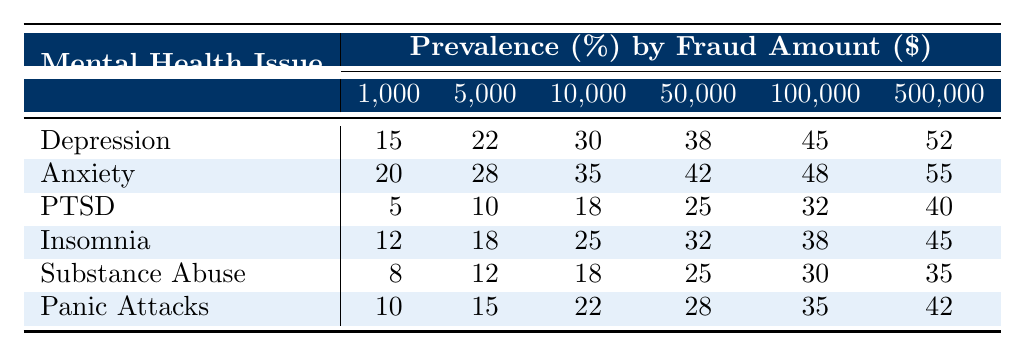What is the prevalence of Depression among victims who experienced $100,000 in fraud? The table indicates that the prevalence of Depression at the $100,000 fraud amount is 45%.
Answer: 45% Which mental health issue has the highest prevalence at a fraud amount of $500,000? By looking at the $500,000 column, Anxiety has the highest prevalence at 55%.
Answer: Anxiety What is the difference in prevalence between PTSD and Insomnia for a fraud amount of $10,000? The prevalence of PTSD at $10,000 is 18%, while for Insomnia it is 25%. The difference is 25% - 18% = 7%.
Answer: 7% Is the prevalence of Substance Abuse higher than that of Panic Attacks at a fraud amount of $50,000? At $50,000, the prevalence for Substance Abuse is 25%, and for Panic Attacks, it is 28%. Since 25% is less than 28%, the answer is no.
Answer: No What is the average prevalence of anxiety across all fraud amounts? To find the average, sum the prevalence for Anxiety at all amounts: (20 + 28 + 35 + 42 + 48 + 55) = 228. There are 6 amounts, so the average is 228/6 = 38.
Answer: 38% How does the prevalence of Depression change as the fraud amount increases from $1,000 to $500,000? The prevalence of Depression increases from 15% at $1,000 to 52% at $500,000. This indicates an upward trend, demonstrating a strong relation between higher fraud amounts and increased prevalence.
Answer: Increases Which two mental health issues have the lowest overall prevalence across all fraud amounts? By reviewing the table, PTSD (5%, 10%, 18%, 25%, 32%, 40%) and Substance Abuse (8%, 12%, 18%, 25%, 30%, 35%) have the lowest prevalence.
Answer: PTSD and Substance Abuse What is the total prevalence of mental health issues at a fraud amount of $50,000? Totaling the prevalence for all issues at $50,000 gives: 38 (Depression) + 42 (Anxiety) + 25 (PTSD) + 32 (Insomnia) + 25 (Substance Abuse) + 28 (Panic Attacks) = 190%.
Answer: 190% If we compare the prevalence of PTSD and Insomnia at the fraud amount of $100,000, which has a higher percentage? At $100,000, PTSD has 32% prevalence while Insomnia has 38%. Since 38% is greater than 32%, Insomnia has a higher percentage.
Answer: Insomnia What is the trend in the prevalence of mental health issues as the fraud amount increases? Observing all the rows, we see that most mental health issues exhibit a rising trend in prevalence as the fraud amount increases, indicating that increased financial loss correlates with higher mental health challenges.
Answer: Rising Trend 